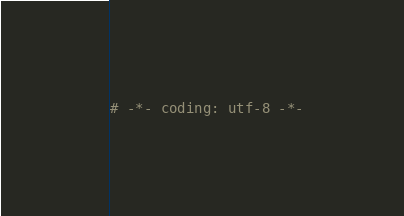Convert code to text. <code><loc_0><loc_0><loc_500><loc_500><_Python_># -*- coding: utf-8 -*-</code> 